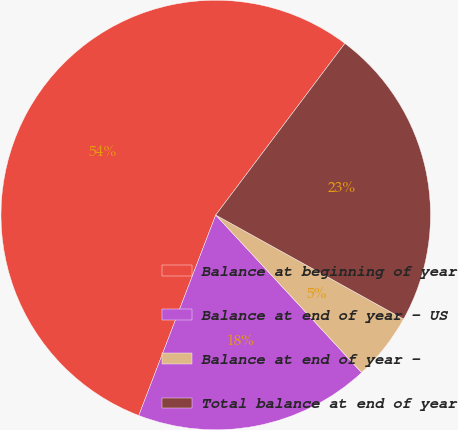<chart> <loc_0><loc_0><loc_500><loc_500><pie_chart><fcel>Balance at beginning of year<fcel>Balance at end of year - US<fcel>Balance at end of year -<fcel>Total balance at end of year<nl><fcel>54.43%<fcel>17.72%<fcel>5.06%<fcel>22.78%<nl></chart> 